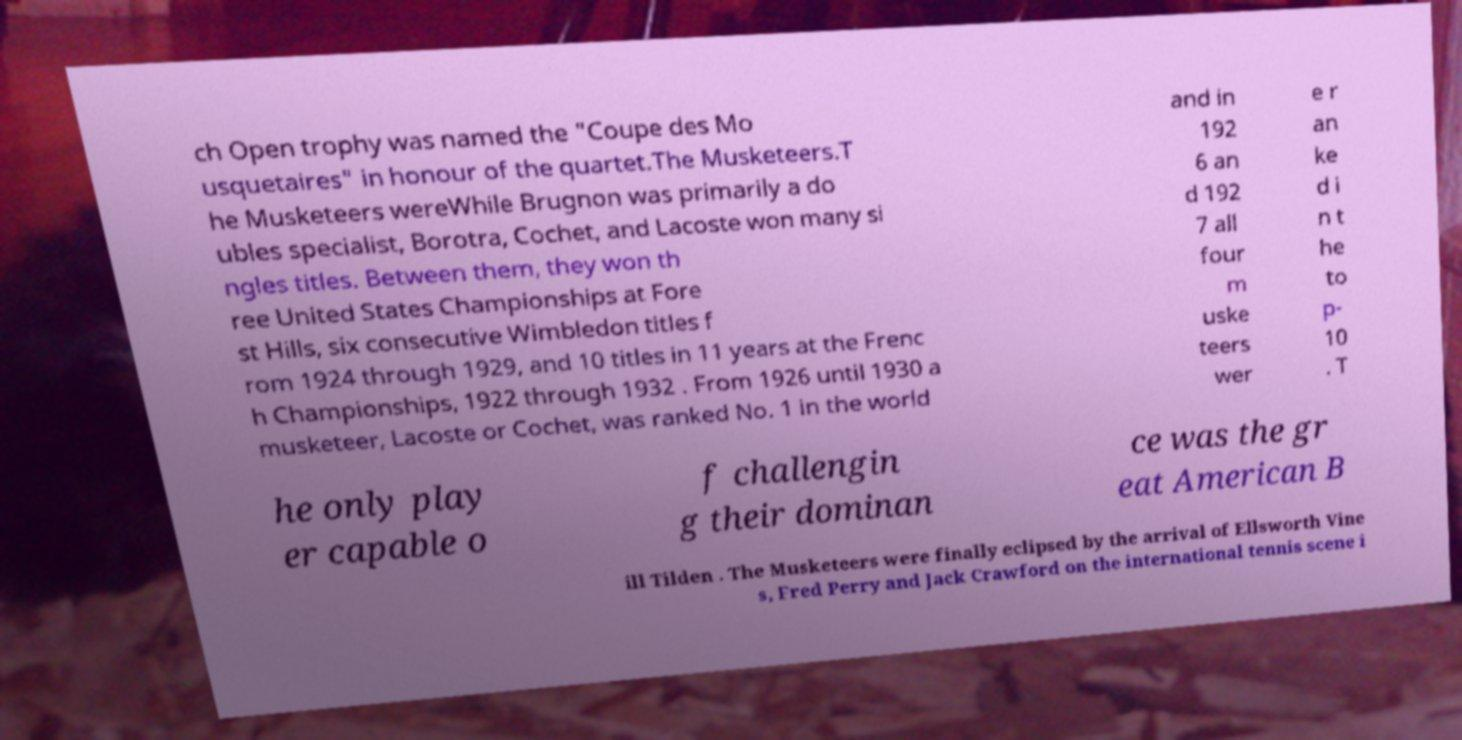What messages or text are displayed in this image? I need them in a readable, typed format. ch Open trophy was named the "Coupe des Mo usquetaires" in honour of the quartet.The Musketeers.T he Musketeers wereWhile Brugnon was primarily a do ubles specialist, Borotra, Cochet, and Lacoste won many si ngles titles. Between them, they won th ree United States Championships at Fore st Hills, six consecutive Wimbledon titles f rom 1924 through 1929, and 10 titles in 11 years at the Frenc h Championships, 1922 through 1932 . From 1926 until 1930 a musketeer, Lacoste or Cochet, was ranked No. 1 in the world and in 192 6 an d 192 7 all four m uske teers wer e r an ke d i n t he to p- 10 . T he only play er capable o f challengin g their dominan ce was the gr eat American B ill Tilden . The Musketeers were finally eclipsed by the arrival of Ellsworth Vine s, Fred Perry and Jack Crawford on the international tennis scene i 